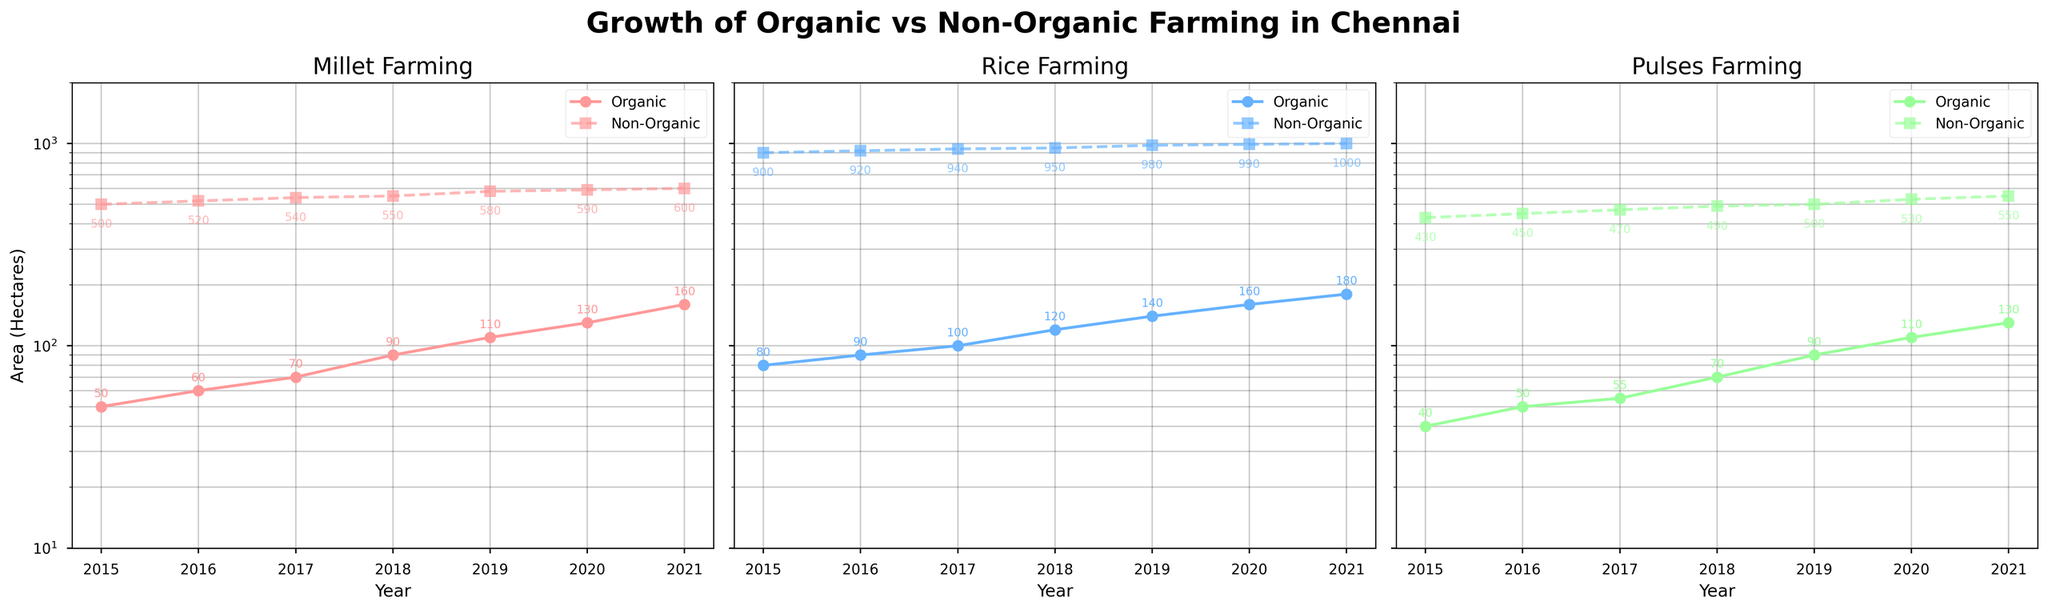What's the total area of organic rice farming in 2021? By looking at the 'Rice Farming' subplot, find the organic rice data point for the year 2021 on the x-axis and check the y-axis value for the area in hectares. In 2021, the area for organic rice farming is marked as 180 hectares.
Answer: 180 hectares How did the yield of non-organic pulses change from 2015 to 2021? Refer to the subplot for 'Pulses Farming'. Find the non-organic pulses data points and compare the yield values in 2015 (1000 kg/ha) and 2021 (1300 kg/ha). The change in yield is 1300 - 1000 = 300 kg/ha.
Answer: Increased by 300 kg/ha In which crop did organic farming see the highest increase in farming area from 2015 to 2021? Compare the starting and ending points in each of the three subplots for organic farming. For Millet, the increase is from 50 to 160 hectares (110 hectares). For Rice, the increase is from 80 to 180 hectares (100 hectares). For Pulses, the increase is from 40 to 130 hectares (90 hectares). The highest increase is in Millet.
Answer: Millet How does the farming area of non-organic rice in 2021 compare to that of organic pulses in 2019? Check the non-organic rice area in 2021, which is 1000 hectares. Then, check the organic pulses area in 2019, which is 90 hectares. Compare the two values: 1000 hectares (non-organic rice) is significantly larger than 90 hectares (organic pulses).
Answer: Non-organic rice area is much larger What was the yield difference between organic and non-organic rice in 2020? Look at the 'Rice Farming' subplot and find the yield for both organic (4300 kg/ha) and non-organic (4950 kg/ha) rice in 2020. The difference is 4950 - 4300 = 650 kg/ha.
Answer: 650 kg/ha In which year did organic millet farming cross 100 hectares? Refer to the 'Millet Farming' subplot and find the point where the organic area exceeds 100 hectares. This happens in 2019 when the area reaches 110 hectares.
Answer: 2019 Which type of farming had a more consistent growth in the area for Rice from 2015 to 2021? By observing the slope of the lines in the 'Rice Farming' subplot, both organic and non-organic lines are approximately linear. However, the non-organic farming's slope visually appears more consistent than the organic farming as it increases incrementally without any major jumps.
Answer: Non-Organic Which crop in organic farming had the smallest area in 2015? Look at the starting points for all organic crops in 2015 in their respective subplots. Millet has 50 hectares, Rice has 80 hectares, and Pulses have 40 hectares. The smallest area is for Pulses with 40 hectares.
Answer: Pulses By what factor did the area of organic rice farming increase from 2015 to 2021? The area for organic rice farming increased from 80 hectares in 2015 to 180 hectares in 2021. The factor of increase is calculated as 180 / 80 = 2.25.
Answer: 2.25 